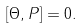Convert formula to latex. <formula><loc_0><loc_0><loc_500><loc_500>[ { \Theta } , P ] = 0 .</formula> 